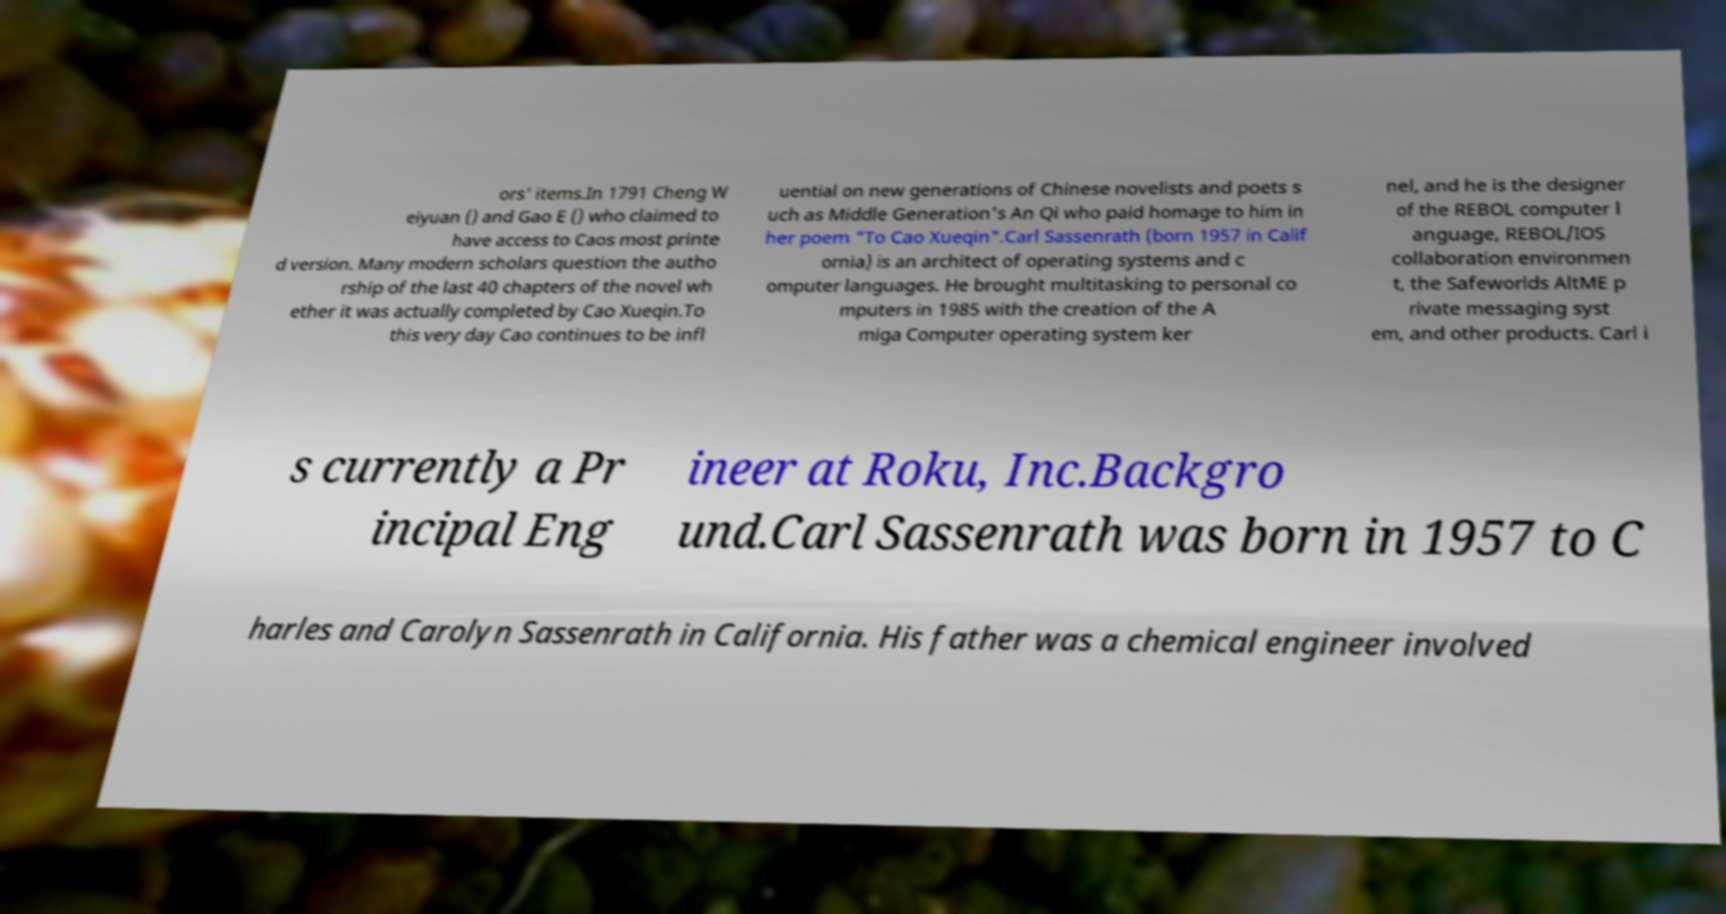What messages or text are displayed in this image? I need them in a readable, typed format. ors' items.In 1791 Cheng W eiyuan () and Gao E () who claimed to have access to Caos most printe d version. Many modern scholars question the autho rship of the last 40 chapters of the novel wh ether it was actually completed by Cao Xueqin.To this very day Cao continues to be infl uential on new generations of Chinese novelists and poets s uch as Middle Generation's An Qi who paid homage to him in her poem "To Cao Xueqin".Carl Sassenrath (born 1957 in Calif ornia) is an architect of operating systems and c omputer languages. He brought multitasking to personal co mputers in 1985 with the creation of the A miga Computer operating system ker nel, and he is the designer of the REBOL computer l anguage, REBOL/IOS collaboration environmen t, the Safeworlds AltME p rivate messaging syst em, and other products. Carl i s currently a Pr incipal Eng ineer at Roku, Inc.Backgro und.Carl Sassenrath was born in 1957 to C harles and Carolyn Sassenrath in California. His father was a chemical engineer involved 